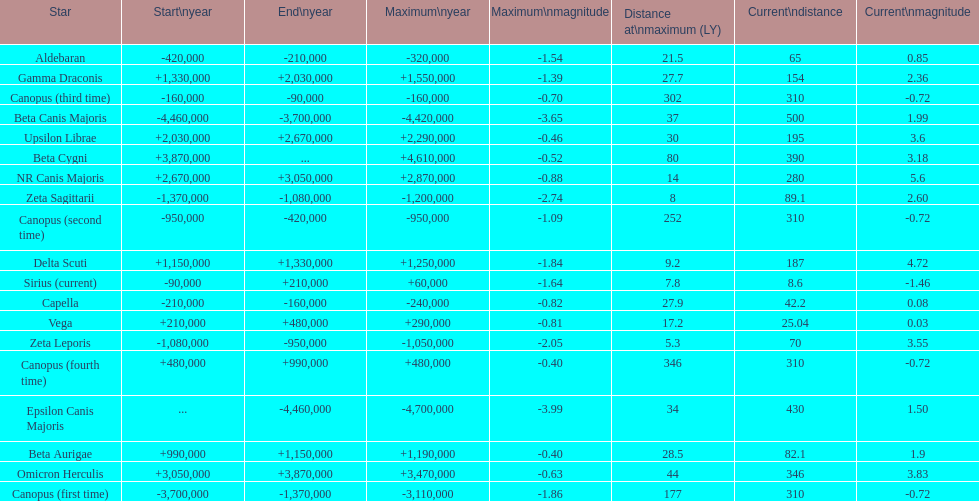Which star has the highest distance at maximum? Canopus (fourth time). 